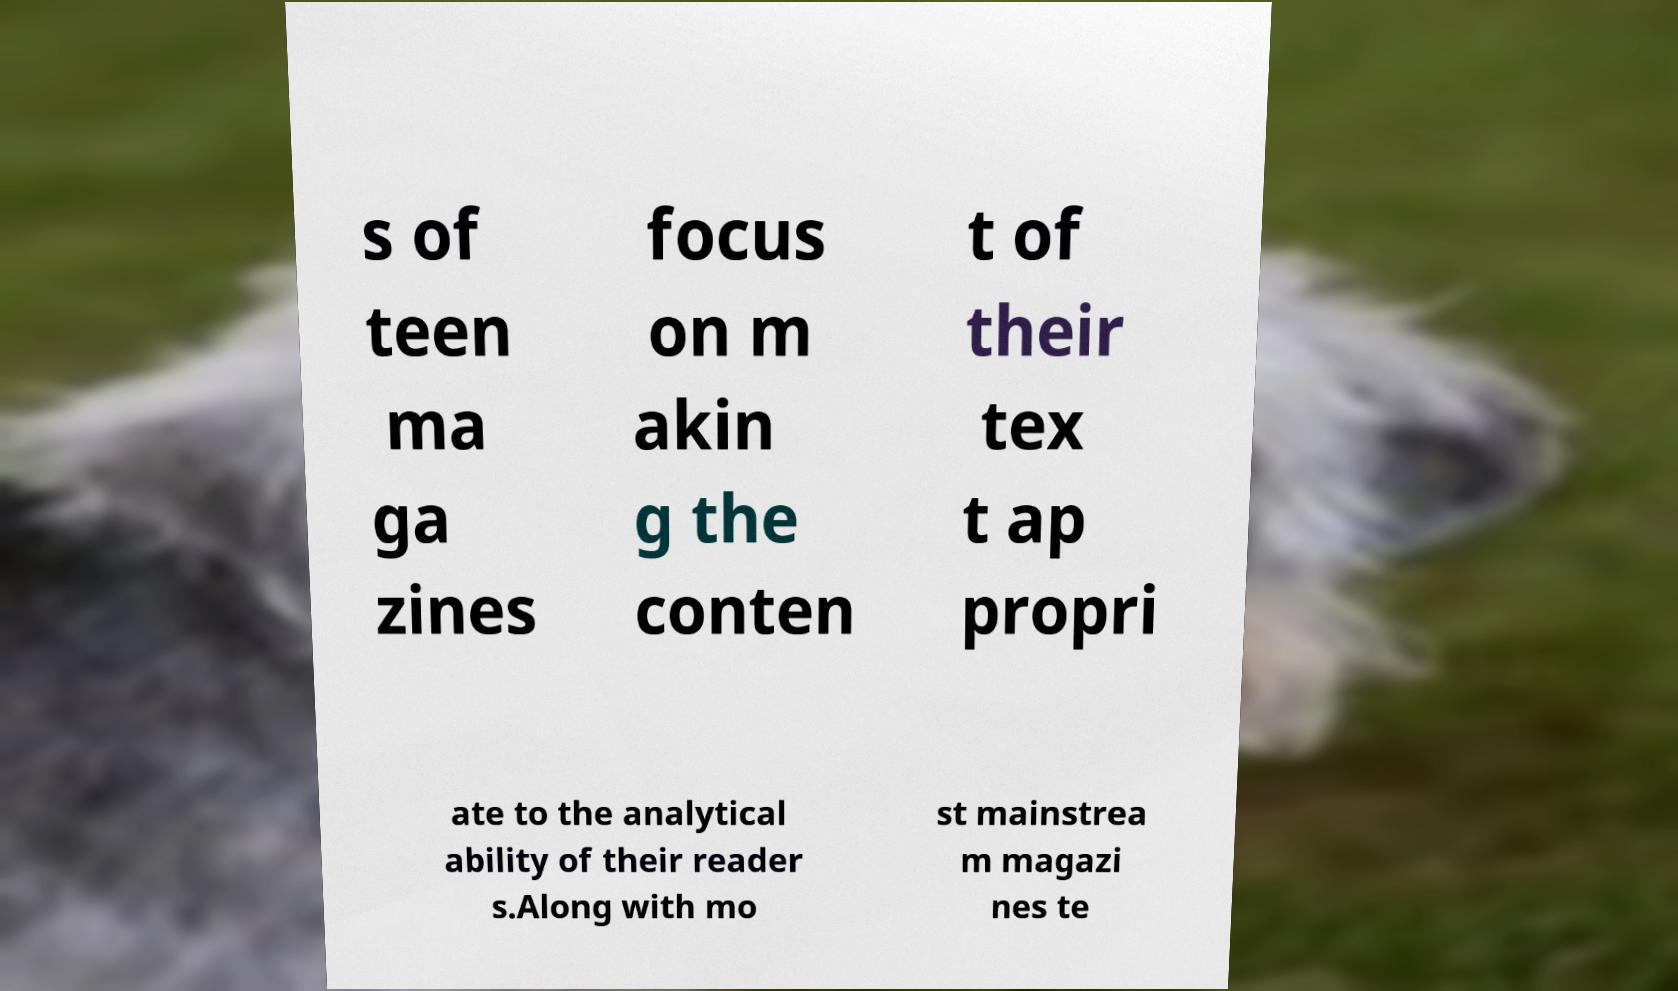Can you read and provide the text displayed in the image?This photo seems to have some interesting text. Can you extract and type it out for me? s of teen ma ga zines focus on m akin g the conten t of their tex t ap propri ate to the analytical ability of their reader s.Along with mo st mainstrea m magazi nes te 